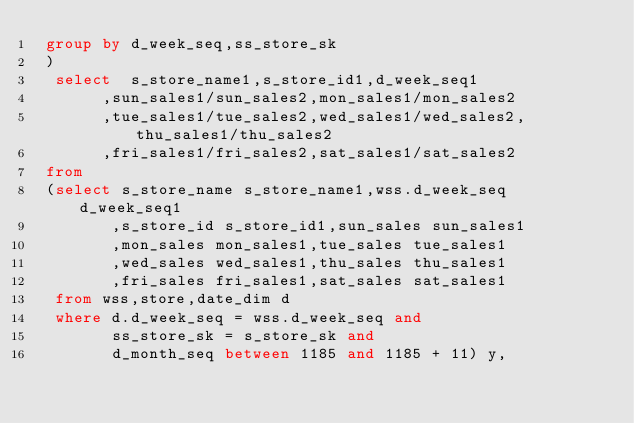Convert code to text. <code><loc_0><loc_0><loc_500><loc_500><_SQL_> group by d_week_seq,ss_store_sk
 )
  select  s_store_name1,s_store_id1,d_week_seq1
       ,sun_sales1/sun_sales2,mon_sales1/mon_sales2
       ,tue_sales1/tue_sales2,wed_sales1/wed_sales2,thu_sales1/thu_sales2
       ,fri_sales1/fri_sales2,sat_sales1/sat_sales2
 from
 (select s_store_name s_store_name1,wss.d_week_seq d_week_seq1
        ,s_store_id s_store_id1,sun_sales sun_sales1
        ,mon_sales mon_sales1,tue_sales tue_sales1
        ,wed_sales wed_sales1,thu_sales thu_sales1
        ,fri_sales fri_sales1,sat_sales sat_sales1
  from wss,store,date_dim d
  where d.d_week_seq = wss.d_week_seq and
        ss_store_sk = s_store_sk and
        d_month_seq between 1185 and 1185 + 11) y,</code> 